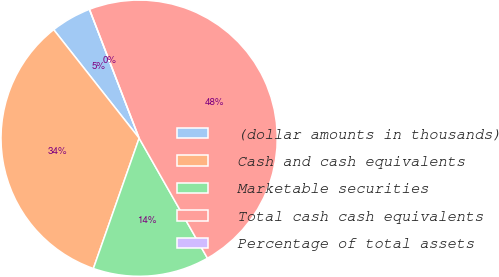Convert chart to OTSL. <chart><loc_0><loc_0><loc_500><loc_500><pie_chart><fcel>(dollar amounts in thousands)<fcel>Cash and cash equivalents<fcel>Marketable securities<fcel>Total cash cash equivalents<fcel>Percentage of total assets<nl><fcel>4.76%<fcel>34.01%<fcel>13.61%<fcel>47.62%<fcel>0.0%<nl></chart> 